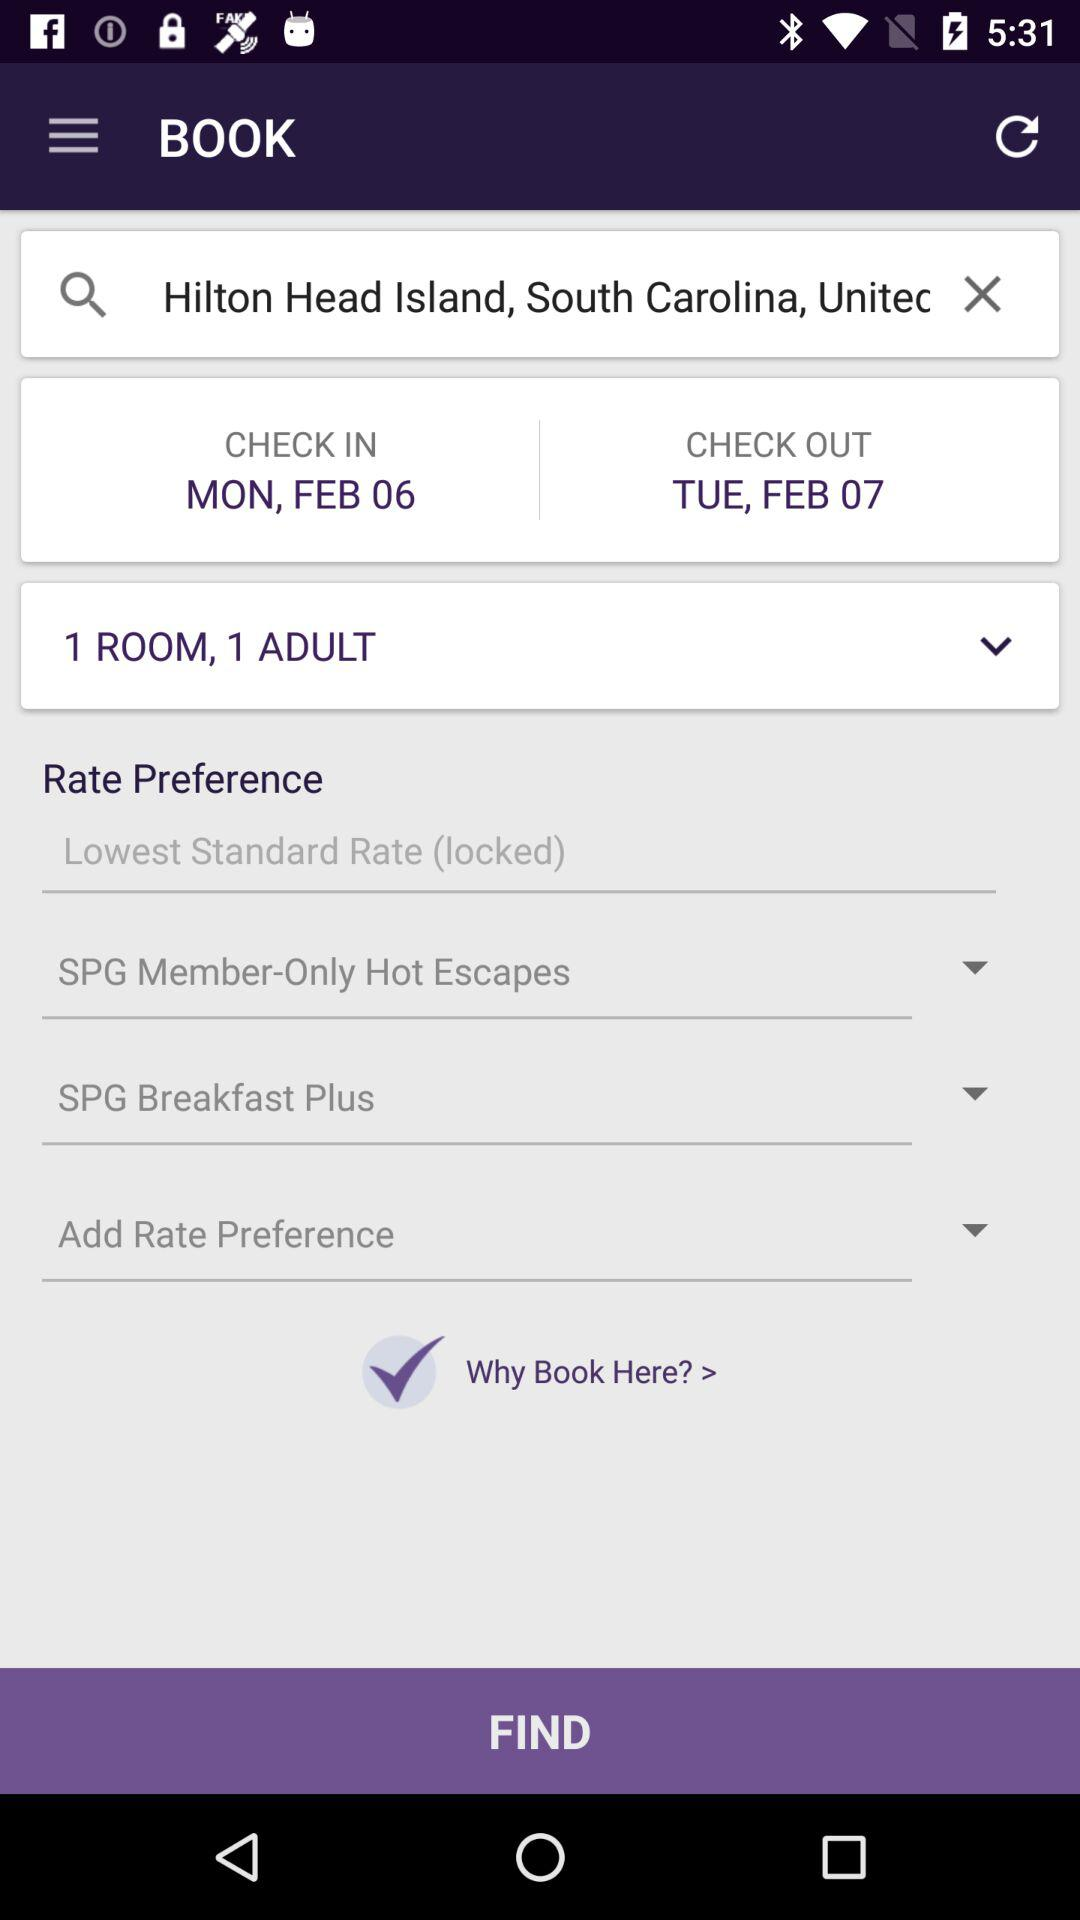How many rooms are selected for booking? The number of rooms that are selected for booking is 1. 